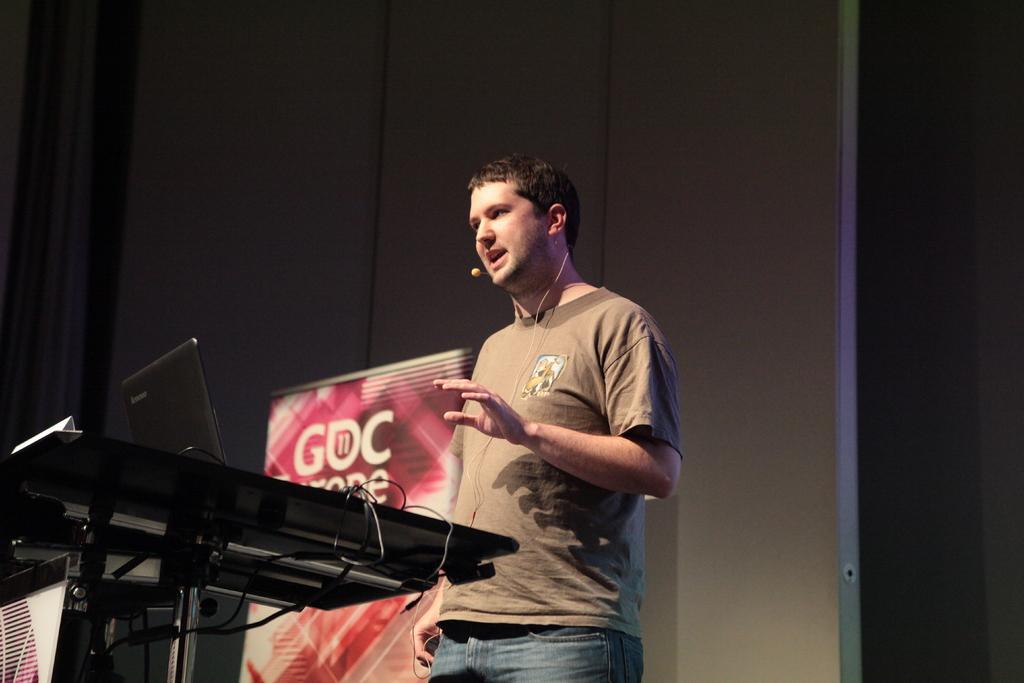Please provide a concise description of this image. In this image we can see one person standing near to the table and talking. There is one banner with some text, near to the wall, some wires, one laptop on a table, one curtain and one banner attached to the table. 